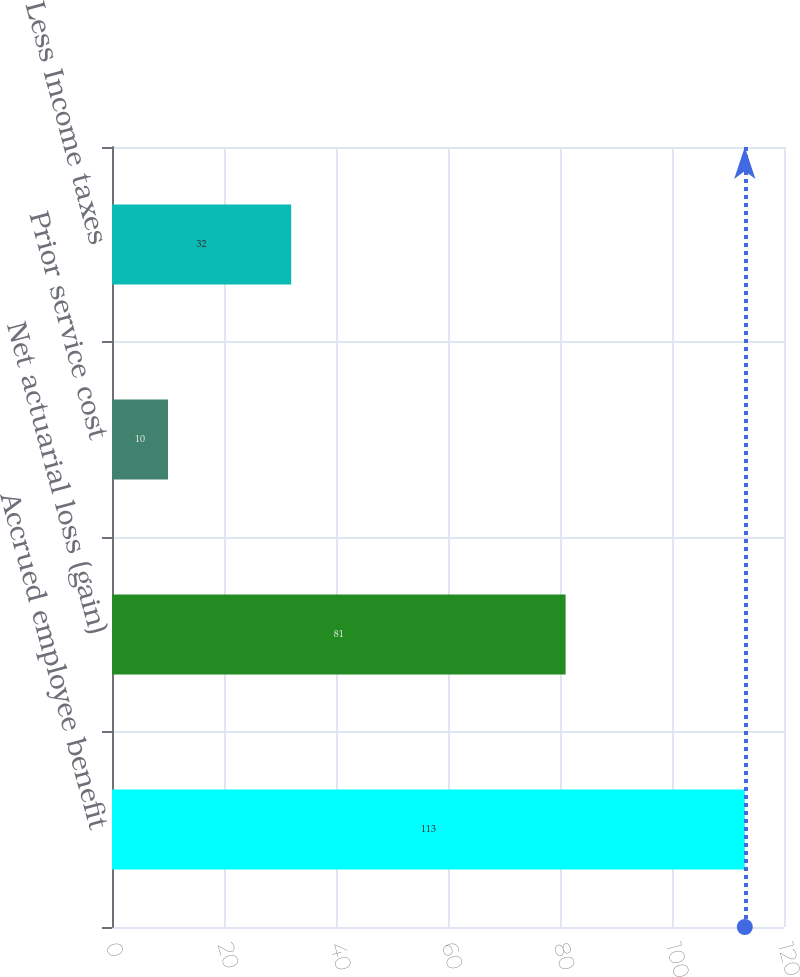<chart> <loc_0><loc_0><loc_500><loc_500><bar_chart><fcel>Accrued employee benefit<fcel>Net actuarial loss (gain)<fcel>Prior service cost<fcel>Less Income taxes<nl><fcel>113<fcel>81<fcel>10<fcel>32<nl></chart> 